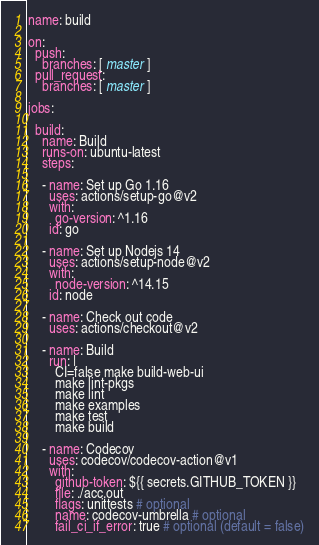<code> <loc_0><loc_0><loc_500><loc_500><_YAML_>name: build

on:
  push:
    branches: [ master ]
  pull_request:
    branches: [ master ]

jobs:

  build:
    name: Build
    runs-on: ubuntu-latest
    steps:

    - name: Set up Go 1.16
      uses: actions/setup-go@v2
      with:
        go-version: ^1.16
      id: go

    - name: Set up Nodejs 14
      uses: actions/setup-node@v2
      with:
        node-version: ^14.15
      id: node

    - name: Check out code
      uses: actions/checkout@v2

    - name: Build
      run: |
        CI=false make build-web-ui
        make lint-pkgs
        make lint
        make examples
        make test
        make build

    - name: Codecov
      uses: codecov/codecov-action@v1
      with:
        github-token: ${{ secrets.GITHUB_TOKEN }}
        file: ./acc.out
        flags: unittests # optional
        name: codecov-umbrella # optional
        fail_ci_if_error: true # optional (default = false)
</code> 